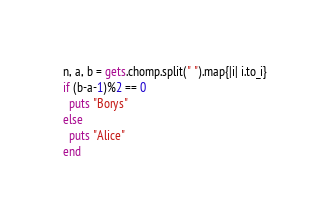<code> <loc_0><loc_0><loc_500><loc_500><_Ruby_>n, a, b = gets.chomp.split(" ").map{|i| i.to_i}
if (b-a-1)%2 == 0
  puts "Borys"
else
  puts "Alice"
end
</code> 